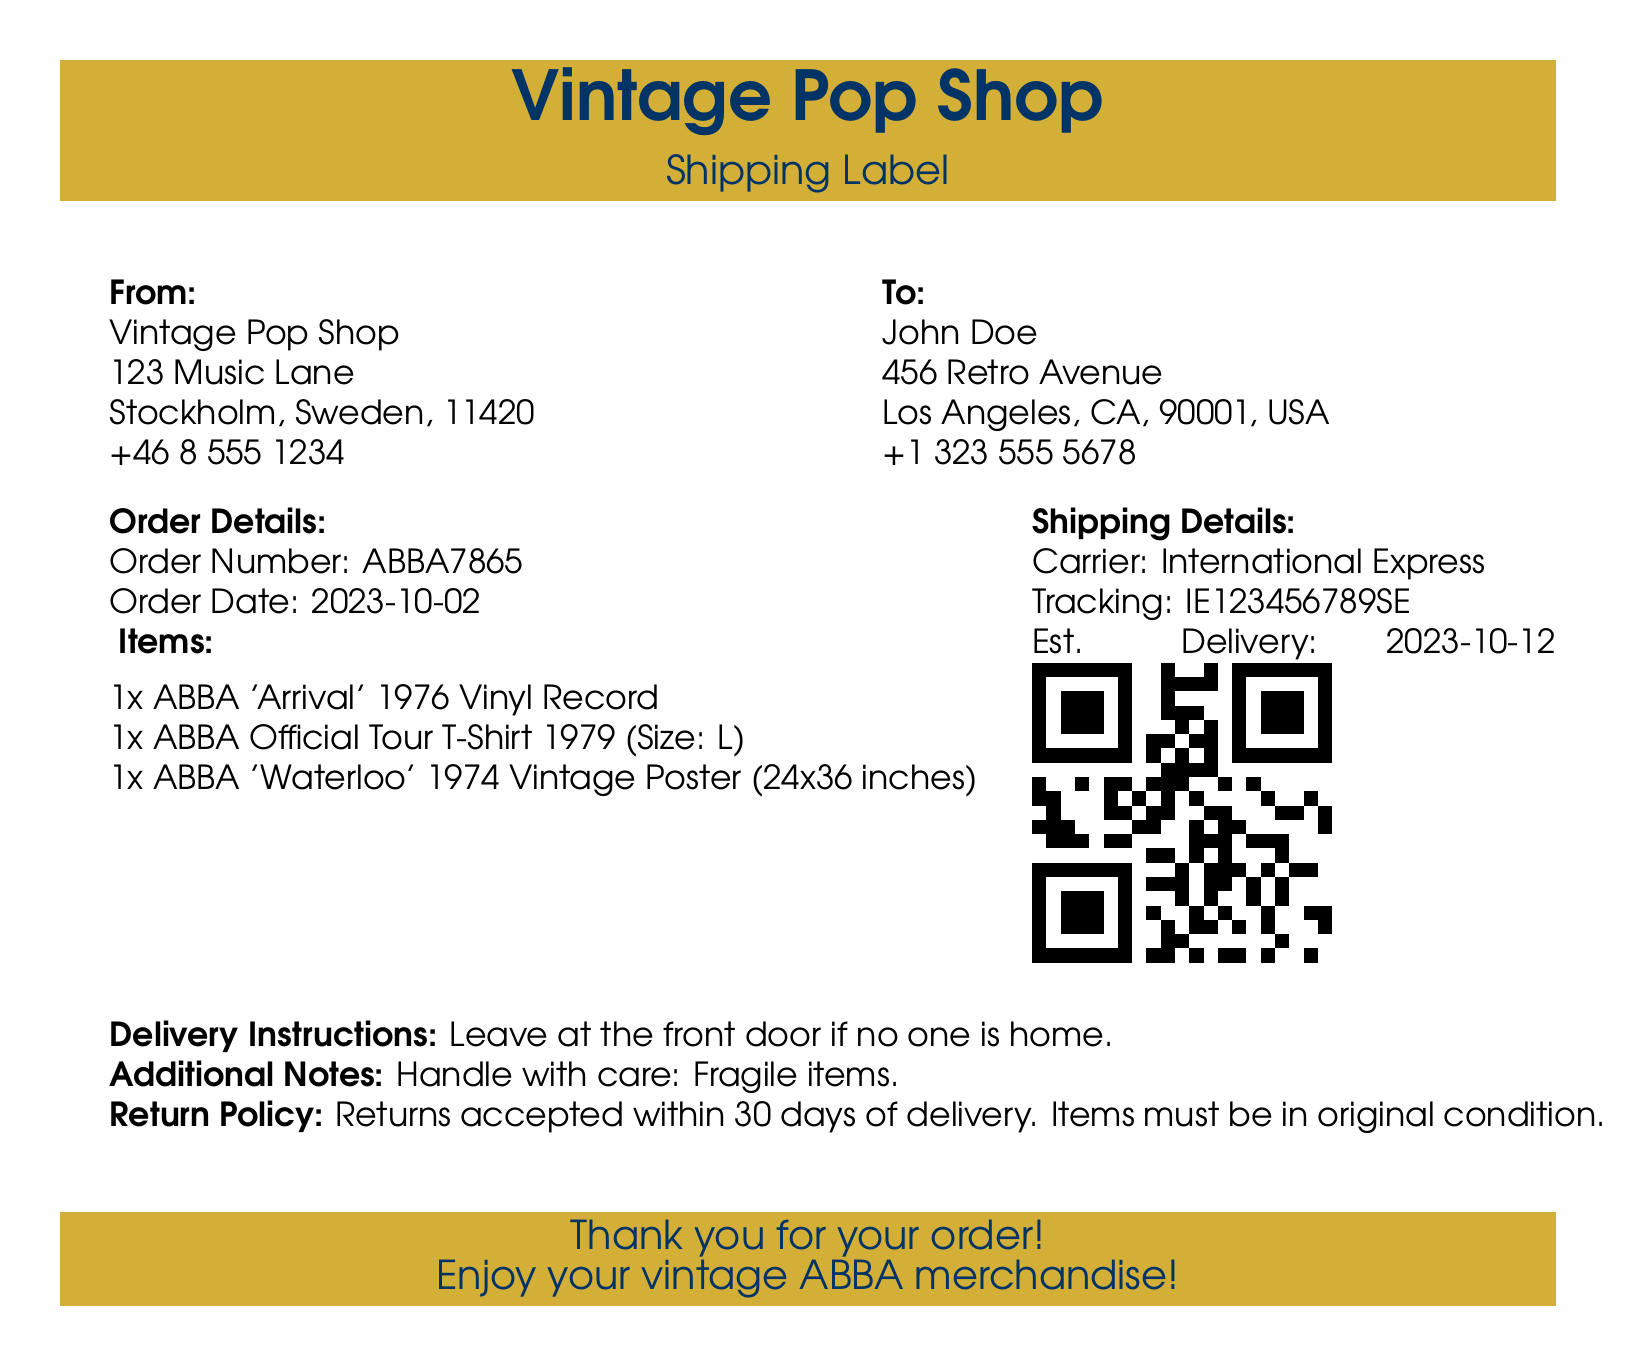what is the order number? The order number is indicated in the order details section of the document.
Answer: ABBA7865 who is the recipient? The recipient's name is provided in the shipping label section.
Answer: John Doe what is the estimated delivery date? The estimated delivery date is specified in the shipping details section.
Answer: 2023-10-12 how many items are listed in the order? The number of items can be counted from the items section within the order details.
Answer: 3 what is the contact number of the sender? The sender's contact number is listed under the "From" section of the document.
Answer: +46 8 555 1234 what is the size of the t-shirt ordered? The size of the t-shirt is noted in the order details section.
Answer: L what is the tracking number? The tracking number can be found in the shipping details section of the document.
Answer: IE123456789SE what should be done with fragile items? Additional notes regarding handling are provided in the document.
Answer: Handle with care what is the return policy? The return policy is stated in the delivery instructions of the document.
Answer: Returns accepted within 30 days of delivery 